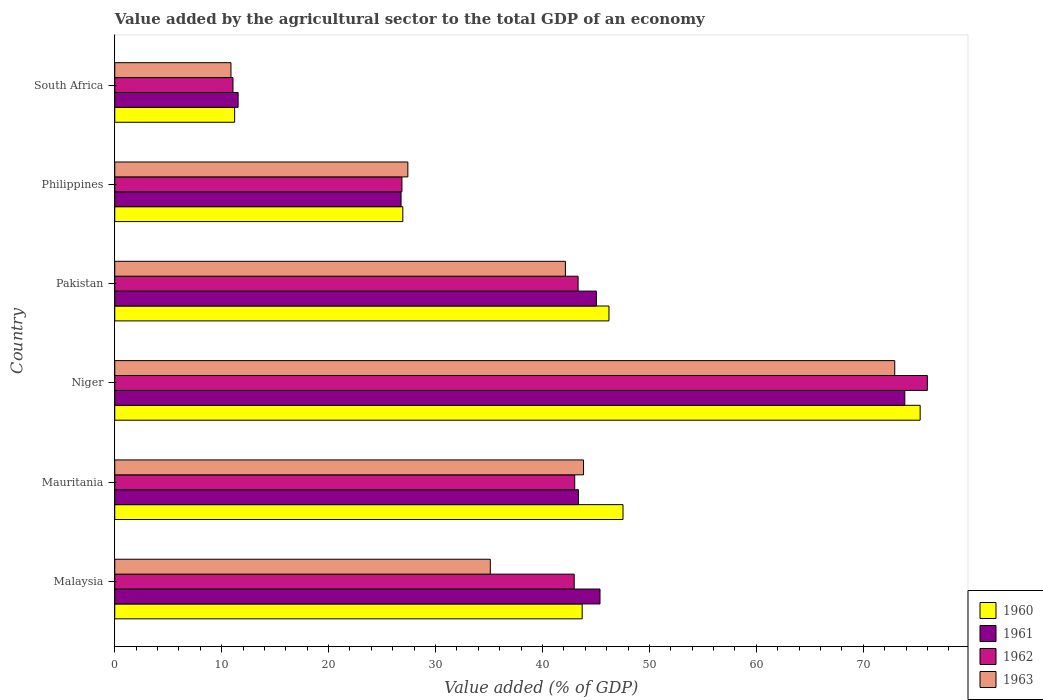How many groups of bars are there?
Your answer should be very brief. 6. Are the number of bars per tick equal to the number of legend labels?
Give a very brief answer. Yes. Are the number of bars on each tick of the Y-axis equal?
Make the answer very short. Yes. How many bars are there on the 2nd tick from the top?
Provide a succinct answer. 4. How many bars are there on the 6th tick from the bottom?
Your answer should be compact. 4. What is the label of the 1st group of bars from the top?
Offer a very short reply. South Africa. What is the value added by the agricultural sector to the total GDP in 1961 in South Africa?
Your response must be concise. 11.54. Across all countries, what is the maximum value added by the agricultural sector to the total GDP in 1963?
Give a very brief answer. 72.95. Across all countries, what is the minimum value added by the agricultural sector to the total GDP in 1963?
Make the answer very short. 10.87. In which country was the value added by the agricultural sector to the total GDP in 1962 maximum?
Make the answer very short. Niger. In which country was the value added by the agricultural sector to the total GDP in 1960 minimum?
Provide a succinct answer. South Africa. What is the total value added by the agricultural sector to the total GDP in 1960 in the graph?
Give a very brief answer. 250.95. What is the difference between the value added by the agricultural sector to the total GDP in 1963 in Malaysia and that in South Africa?
Your answer should be very brief. 24.25. What is the difference between the value added by the agricultural sector to the total GDP in 1963 in Malaysia and the value added by the agricultural sector to the total GDP in 1960 in Mauritania?
Make the answer very short. -12.41. What is the average value added by the agricultural sector to the total GDP in 1963 per country?
Offer a terse response. 38.72. What is the difference between the value added by the agricultural sector to the total GDP in 1963 and value added by the agricultural sector to the total GDP in 1961 in South Africa?
Provide a succinct answer. -0.67. What is the ratio of the value added by the agricultural sector to the total GDP in 1960 in Malaysia to that in Pakistan?
Offer a terse response. 0.95. Is the difference between the value added by the agricultural sector to the total GDP in 1963 in Mauritania and Pakistan greater than the difference between the value added by the agricultural sector to the total GDP in 1961 in Mauritania and Pakistan?
Your answer should be very brief. Yes. What is the difference between the highest and the second highest value added by the agricultural sector to the total GDP in 1962?
Your answer should be very brief. 32.66. What is the difference between the highest and the lowest value added by the agricultural sector to the total GDP in 1961?
Make the answer very short. 62.35. Is the sum of the value added by the agricultural sector to the total GDP in 1960 in Malaysia and Niger greater than the maximum value added by the agricultural sector to the total GDP in 1961 across all countries?
Offer a very short reply. Yes. Is it the case that in every country, the sum of the value added by the agricultural sector to the total GDP in 1963 and value added by the agricultural sector to the total GDP in 1962 is greater than the sum of value added by the agricultural sector to the total GDP in 1961 and value added by the agricultural sector to the total GDP in 1960?
Offer a terse response. No. What does the 1st bar from the top in Mauritania represents?
Your answer should be very brief. 1963. What does the 3rd bar from the bottom in Malaysia represents?
Your answer should be very brief. 1962. Are all the bars in the graph horizontal?
Keep it short and to the point. Yes. How many countries are there in the graph?
Your answer should be very brief. 6. Does the graph contain grids?
Your answer should be compact. No. What is the title of the graph?
Provide a succinct answer. Value added by the agricultural sector to the total GDP of an economy. Does "1986" appear as one of the legend labels in the graph?
Make the answer very short. No. What is the label or title of the X-axis?
Your answer should be compact. Value added (% of GDP). What is the label or title of the Y-axis?
Ensure brevity in your answer.  Country. What is the Value added (% of GDP) of 1960 in Malaysia?
Provide a short and direct response. 43.72. What is the Value added (% of GDP) of 1961 in Malaysia?
Provide a short and direct response. 45.38. What is the Value added (% of GDP) in 1962 in Malaysia?
Your answer should be very brief. 42.97. What is the Value added (% of GDP) in 1963 in Malaysia?
Keep it short and to the point. 35.12. What is the Value added (% of GDP) of 1960 in Mauritania?
Provide a short and direct response. 47.53. What is the Value added (% of GDP) in 1961 in Mauritania?
Provide a succinct answer. 43.37. What is the Value added (% of GDP) of 1962 in Mauritania?
Your answer should be compact. 43.02. What is the Value added (% of GDP) of 1963 in Mauritania?
Provide a short and direct response. 43.84. What is the Value added (% of GDP) of 1960 in Niger?
Your answer should be compact. 75.32. What is the Value added (% of GDP) of 1961 in Niger?
Your response must be concise. 73.89. What is the Value added (% of GDP) of 1962 in Niger?
Offer a very short reply. 76. What is the Value added (% of GDP) in 1963 in Niger?
Your answer should be compact. 72.95. What is the Value added (% of GDP) of 1960 in Pakistan?
Offer a very short reply. 46.22. What is the Value added (% of GDP) in 1961 in Pakistan?
Give a very brief answer. 45.04. What is the Value added (% of GDP) of 1962 in Pakistan?
Give a very brief answer. 43.33. What is the Value added (% of GDP) in 1963 in Pakistan?
Provide a short and direct response. 42.15. What is the Value added (% of GDP) of 1960 in Philippines?
Provide a succinct answer. 26.94. What is the Value added (% of GDP) in 1961 in Philippines?
Offer a terse response. 26.78. What is the Value added (% of GDP) of 1962 in Philippines?
Offer a very short reply. 26.86. What is the Value added (% of GDP) in 1963 in Philippines?
Provide a succinct answer. 27.41. What is the Value added (% of GDP) of 1960 in South Africa?
Your answer should be compact. 11.21. What is the Value added (% of GDP) in 1961 in South Africa?
Your response must be concise. 11.54. What is the Value added (% of GDP) in 1962 in South Africa?
Your response must be concise. 11.06. What is the Value added (% of GDP) in 1963 in South Africa?
Offer a terse response. 10.87. Across all countries, what is the maximum Value added (% of GDP) in 1960?
Keep it short and to the point. 75.32. Across all countries, what is the maximum Value added (% of GDP) in 1961?
Make the answer very short. 73.89. Across all countries, what is the maximum Value added (% of GDP) of 1962?
Keep it short and to the point. 76. Across all countries, what is the maximum Value added (% of GDP) in 1963?
Keep it short and to the point. 72.95. Across all countries, what is the minimum Value added (% of GDP) of 1960?
Offer a very short reply. 11.21. Across all countries, what is the minimum Value added (% of GDP) of 1961?
Give a very brief answer. 11.54. Across all countries, what is the minimum Value added (% of GDP) of 1962?
Give a very brief answer. 11.06. Across all countries, what is the minimum Value added (% of GDP) in 1963?
Your answer should be compact. 10.87. What is the total Value added (% of GDP) of 1960 in the graph?
Make the answer very short. 250.95. What is the total Value added (% of GDP) of 1961 in the graph?
Keep it short and to the point. 245.99. What is the total Value added (% of GDP) in 1962 in the graph?
Keep it short and to the point. 243.23. What is the total Value added (% of GDP) of 1963 in the graph?
Provide a succinct answer. 232.34. What is the difference between the Value added (% of GDP) of 1960 in Malaysia and that in Mauritania?
Ensure brevity in your answer.  -3.82. What is the difference between the Value added (% of GDP) of 1961 in Malaysia and that in Mauritania?
Your response must be concise. 2.01. What is the difference between the Value added (% of GDP) of 1963 in Malaysia and that in Mauritania?
Offer a terse response. -8.72. What is the difference between the Value added (% of GDP) of 1960 in Malaysia and that in Niger?
Make the answer very short. -31.61. What is the difference between the Value added (% of GDP) of 1961 in Malaysia and that in Niger?
Ensure brevity in your answer.  -28.5. What is the difference between the Value added (% of GDP) of 1962 in Malaysia and that in Niger?
Offer a terse response. -33.03. What is the difference between the Value added (% of GDP) of 1963 in Malaysia and that in Niger?
Make the answer very short. -37.82. What is the difference between the Value added (% of GDP) in 1960 in Malaysia and that in Pakistan?
Make the answer very short. -2.5. What is the difference between the Value added (% of GDP) of 1961 in Malaysia and that in Pakistan?
Offer a terse response. 0.34. What is the difference between the Value added (% of GDP) of 1962 in Malaysia and that in Pakistan?
Keep it short and to the point. -0.36. What is the difference between the Value added (% of GDP) in 1963 in Malaysia and that in Pakistan?
Provide a succinct answer. -7.02. What is the difference between the Value added (% of GDP) in 1960 in Malaysia and that in Philippines?
Offer a terse response. 16.78. What is the difference between the Value added (% of GDP) in 1961 in Malaysia and that in Philippines?
Your answer should be very brief. 18.61. What is the difference between the Value added (% of GDP) of 1962 in Malaysia and that in Philippines?
Give a very brief answer. 16.11. What is the difference between the Value added (% of GDP) of 1963 in Malaysia and that in Philippines?
Your response must be concise. 7.71. What is the difference between the Value added (% of GDP) in 1960 in Malaysia and that in South Africa?
Give a very brief answer. 32.51. What is the difference between the Value added (% of GDP) of 1961 in Malaysia and that in South Africa?
Offer a very short reply. 33.84. What is the difference between the Value added (% of GDP) of 1962 in Malaysia and that in South Africa?
Your response must be concise. 31.91. What is the difference between the Value added (% of GDP) in 1963 in Malaysia and that in South Africa?
Your answer should be very brief. 24.25. What is the difference between the Value added (% of GDP) in 1960 in Mauritania and that in Niger?
Keep it short and to the point. -27.79. What is the difference between the Value added (% of GDP) of 1961 in Mauritania and that in Niger?
Your answer should be very brief. -30.52. What is the difference between the Value added (% of GDP) of 1962 in Mauritania and that in Niger?
Your answer should be very brief. -32.98. What is the difference between the Value added (% of GDP) in 1963 in Mauritania and that in Niger?
Offer a very short reply. -29.11. What is the difference between the Value added (% of GDP) in 1960 in Mauritania and that in Pakistan?
Offer a very short reply. 1.31. What is the difference between the Value added (% of GDP) of 1961 in Mauritania and that in Pakistan?
Keep it short and to the point. -1.68. What is the difference between the Value added (% of GDP) of 1962 in Mauritania and that in Pakistan?
Provide a succinct answer. -0.31. What is the difference between the Value added (% of GDP) of 1963 in Mauritania and that in Pakistan?
Your answer should be compact. 1.69. What is the difference between the Value added (% of GDP) in 1960 in Mauritania and that in Philippines?
Your answer should be very brief. 20.59. What is the difference between the Value added (% of GDP) in 1961 in Mauritania and that in Philippines?
Provide a succinct answer. 16.59. What is the difference between the Value added (% of GDP) of 1962 in Mauritania and that in Philippines?
Your response must be concise. 16.16. What is the difference between the Value added (% of GDP) in 1963 in Mauritania and that in Philippines?
Offer a very short reply. 16.43. What is the difference between the Value added (% of GDP) of 1960 in Mauritania and that in South Africa?
Make the answer very short. 36.32. What is the difference between the Value added (% of GDP) of 1961 in Mauritania and that in South Africa?
Offer a terse response. 31.83. What is the difference between the Value added (% of GDP) of 1962 in Mauritania and that in South Africa?
Keep it short and to the point. 31.96. What is the difference between the Value added (% of GDP) in 1963 in Mauritania and that in South Africa?
Offer a very short reply. 32.97. What is the difference between the Value added (% of GDP) in 1960 in Niger and that in Pakistan?
Offer a terse response. 29.1. What is the difference between the Value added (% of GDP) of 1961 in Niger and that in Pakistan?
Your response must be concise. 28.84. What is the difference between the Value added (% of GDP) in 1962 in Niger and that in Pakistan?
Keep it short and to the point. 32.66. What is the difference between the Value added (% of GDP) of 1963 in Niger and that in Pakistan?
Make the answer very short. 30.8. What is the difference between the Value added (% of GDP) of 1960 in Niger and that in Philippines?
Your answer should be compact. 48.38. What is the difference between the Value added (% of GDP) of 1961 in Niger and that in Philippines?
Keep it short and to the point. 47.11. What is the difference between the Value added (% of GDP) in 1962 in Niger and that in Philippines?
Offer a terse response. 49.14. What is the difference between the Value added (% of GDP) of 1963 in Niger and that in Philippines?
Make the answer very short. 45.54. What is the difference between the Value added (% of GDP) in 1960 in Niger and that in South Africa?
Give a very brief answer. 64.11. What is the difference between the Value added (% of GDP) in 1961 in Niger and that in South Africa?
Offer a very short reply. 62.35. What is the difference between the Value added (% of GDP) of 1962 in Niger and that in South Africa?
Your answer should be very brief. 64.94. What is the difference between the Value added (% of GDP) in 1963 in Niger and that in South Africa?
Make the answer very short. 62.08. What is the difference between the Value added (% of GDP) of 1960 in Pakistan and that in Philippines?
Your response must be concise. 19.28. What is the difference between the Value added (% of GDP) of 1961 in Pakistan and that in Philippines?
Keep it short and to the point. 18.27. What is the difference between the Value added (% of GDP) in 1962 in Pakistan and that in Philippines?
Provide a succinct answer. 16.48. What is the difference between the Value added (% of GDP) in 1963 in Pakistan and that in Philippines?
Keep it short and to the point. 14.73. What is the difference between the Value added (% of GDP) of 1960 in Pakistan and that in South Africa?
Your response must be concise. 35.01. What is the difference between the Value added (% of GDP) of 1961 in Pakistan and that in South Africa?
Make the answer very short. 33.51. What is the difference between the Value added (% of GDP) in 1962 in Pakistan and that in South Africa?
Provide a short and direct response. 32.28. What is the difference between the Value added (% of GDP) of 1963 in Pakistan and that in South Africa?
Your answer should be very brief. 31.28. What is the difference between the Value added (% of GDP) of 1960 in Philippines and that in South Africa?
Ensure brevity in your answer.  15.73. What is the difference between the Value added (% of GDP) in 1961 in Philippines and that in South Africa?
Your response must be concise. 15.24. What is the difference between the Value added (% of GDP) in 1962 in Philippines and that in South Africa?
Give a very brief answer. 15.8. What is the difference between the Value added (% of GDP) in 1963 in Philippines and that in South Africa?
Provide a short and direct response. 16.54. What is the difference between the Value added (% of GDP) in 1960 in Malaysia and the Value added (% of GDP) in 1961 in Mauritania?
Keep it short and to the point. 0.35. What is the difference between the Value added (% of GDP) in 1960 in Malaysia and the Value added (% of GDP) in 1962 in Mauritania?
Your answer should be very brief. 0.7. What is the difference between the Value added (% of GDP) of 1960 in Malaysia and the Value added (% of GDP) of 1963 in Mauritania?
Your response must be concise. -0.12. What is the difference between the Value added (% of GDP) in 1961 in Malaysia and the Value added (% of GDP) in 1962 in Mauritania?
Offer a terse response. 2.36. What is the difference between the Value added (% of GDP) in 1961 in Malaysia and the Value added (% of GDP) in 1963 in Mauritania?
Give a very brief answer. 1.54. What is the difference between the Value added (% of GDP) in 1962 in Malaysia and the Value added (% of GDP) in 1963 in Mauritania?
Give a very brief answer. -0.87. What is the difference between the Value added (% of GDP) in 1960 in Malaysia and the Value added (% of GDP) in 1961 in Niger?
Offer a terse response. -30.17. What is the difference between the Value added (% of GDP) in 1960 in Malaysia and the Value added (% of GDP) in 1962 in Niger?
Provide a succinct answer. -32.28. What is the difference between the Value added (% of GDP) of 1960 in Malaysia and the Value added (% of GDP) of 1963 in Niger?
Your response must be concise. -29.23. What is the difference between the Value added (% of GDP) in 1961 in Malaysia and the Value added (% of GDP) in 1962 in Niger?
Your answer should be very brief. -30.62. What is the difference between the Value added (% of GDP) in 1961 in Malaysia and the Value added (% of GDP) in 1963 in Niger?
Offer a very short reply. -27.57. What is the difference between the Value added (% of GDP) in 1962 in Malaysia and the Value added (% of GDP) in 1963 in Niger?
Make the answer very short. -29.98. What is the difference between the Value added (% of GDP) in 1960 in Malaysia and the Value added (% of GDP) in 1961 in Pakistan?
Keep it short and to the point. -1.33. What is the difference between the Value added (% of GDP) in 1960 in Malaysia and the Value added (% of GDP) in 1962 in Pakistan?
Your answer should be very brief. 0.38. What is the difference between the Value added (% of GDP) in 1960 in Malaysia and the Value added (% of GDP) in 1963 in Pakistan?
Keep it short and to the point. 1.57. What is the difference between the Value added (% of GDP) of 1961 in Malaysia and the Value added (% of GDP) of 1962 in Pakistan?
Make the answer very short. 2.05. What is the difference between the Value added (% of GDP) of 1961 in Malaysia and the Value added (% of GDP) of 1963 in Pakistan?
Your answer should be very brief. 3.24. What is the difference between the Value added (% of GDP) of 1962 in Malaysia and the Value added (% of GDP) of 1963 in Pakistan?
Make the answer very short. 0.82. What is the difference between the Value added (% of GDP) in 1960 in Malaysia and the Value added (% of GDP) in 1961 in Philippines?
Provide a succinct answer. 16.94. What is the difference between the Value added (% of GDP) of 1960 in Malaysia and the Value added (% of GDP) of 1962 in Philippines?
Give a very brief answer. 16.86. What is the difference between the Value added (% of GDP) of 1960 in Malaysia and the Value added (% of GDP) of 1963 in Philippines?
Your answer should be very brief. 16.3. What is the difference between the Value added (% of GDP) of 1961 in Malaysia and the Value added (% of GDP) of 1962 in Philippines?
Offer a terse response. 18.52. What is the difference between the Value added (% of GDP) of 1961 in Malaysia and the Value added (% of GDP) of 1963 in Philippines?
Make the answer very short. 17.97. What is the difference between the Value added (% of GDP) in 1962 in Malaysia and the Value added (% of GDP) in 1963 in Philippines?
Offer a terse response. 15.56. What is the difference between the Value added (% of GDP) in 1960 in Malaysia and the Value added (% of GDP) in 1961 in South Africa?
Provide a succinct answer. 32.18. What is the difference between the Value added (% of GDP) in 1960 in Malaysia and the Value added (% of GDP) in 1962 in South Africa?
Your answer should be compact. 32.66. What is the difference between the Value added (% of GDP) of 1960 in Malaysia and the Value added (% of GDP) of 1963 in South Africa?
Your answer should be compact. 32.85. What is the difference between the Value added (% of GDP) of 1961 in Malaysia and the Value added (% of GDP) of 1962 in South Africa?
Your answer should be compact. 34.33. What is the difference between the Value added (% of GDP) in 1961 in Malaysia and the Value added (% of GDP) in 1963 in South Africa?
Your answer should be very brief. 34.51. What is the difference between the Value added (% of GDP) in 1962 in Malaysia and the Value added (% of GDP) in 1963 in South Africa?
Your answer should be compact. 32.1. What is the difference between the Value added (% of GDP) in 1960 in Mauritania and the Value added (% of GDP) in 1961 in Niger?
Your answer should be compact. -26.35. What is the difference between the Value added (% of GDP) in 1960 in Mauritania and the Value added (% of GDP) in 1962 in Niger?
Offer a terse response. -28.46. What is the difference between the Value added (% of GDP) of 1960 in Mauritania and the Value added (% of GDP) of 1963 in Niger?
Keep it short and to the point. -25.41. What is the difference between the Value added (% of GDP) in 1961 in Mauritania and the Value added (% of GDP) in 1962 in Niger?
Provide a short and direct response. -32.63. What is the difference between the Value added (% of GDP) of 1961 in Mauritania and the Value added (% of GDP) of 1963 in Niger?
Offer a very short reply. -29.58. What is the difference between the Value added (% of GDP) of 1962 in Mauritania and the Value added (% of GDP) of 1963 in Niger?
Your response must be concise. -29.93. What is the difference between the Value added (% of GDP) of 1960 in Mauritania and the Value added (% of GDP) of 1961 in Pakistan?
Keep it short and to the point. 2.49. What is the difference between the Value added (% of GDP) of 1960 in Mauritania and the Value added (% of GDP) of 1962 in Pakistan?
Ensure brevity in your answer.  4.2. What is the difference between the Value added (% of GDP) in 1960 in Mauritania and the Value added (% of GDP) in 1963 in Pakistan?
Offer a very short reply. 5.39. What is the difference between the Value added (% of GDP) in 1961 in Mauritania and the Value added (% of GDP) in 1962 in Pakistan?
Provide a succinct answer. 0.03. What is the difference between the Value added (% of GDP) of 1961 in Mauritania and the Value added (% of GDP) of 1963 in Pakistan?
Make the answer very short. 1.22. What is the difference between the Value added (% of GDP) in 1962 in Mauritania and the Value added (% of GDP) in 1963 in Pakistan?
Make the answer very short. 0.87. What is the difference between the Value added (% of GDP) of 1960 in Mauritania and the Value added (% of GDP) of 1961 in Philippines?
Your answer should be compact. 20.76. What is the difference between the Value added (% of GDP) in 1960 in Mauritania and the Value added (% of GDP) in 1962 in Philippines?
Offer a very short reply. 20.68. What is the difference between the Value added (% of GDP) of 1960 in Mauritania and the Value added (% of GDP) of 1963 in Philippines?
Offer a very short reply. 20.12. What is the difference between the Value added (% of GDP) of 1961 in Mauritania and the Value added (% of GDP) of 1962 in Philippines?
Your response must be concise. 16.51. What is the difference between the Value added (% of GDP) in 1961 in Mauritania and the Value added (% of GDP) in 1963 in Philippines?
Provide a short and direct response. 15.96. What is the difference between the Value added (% of GDP) in 1962 in Mauritania and the Value added (% of GDP) in 1963 in Philippines?
Offer a terse response. 15.61. What is the difference between the Value added (% of GDP) of 1960 in Mauritania and the Value added (% of GDP) of 1961 in South Africa?
Offer a terse response. 36. What is the difference between the Value added (% of GDP) of 1960 in Mauritania and the Value added (% of GDP) of 1962 in South Africa?
Make the answer very short. 36.48. What is the difference between the Value added (% of GDP) in 1960 in Mauritania and the Value added (% of GDP) in 1963 in South Africa?
Offer a very short reply. 36.67. What is the difference between the Value added (% of GDP) of 1961 in Mauritania and the Value added (% of GDP) of 1962 in South Africa?
Ensure brevity in your answer.  32.31. What is the difference between the Value added (% of GDP) in 1961 in Mauritania and the Value added (% of GDP) in 1963 in South Africa?
Provide a short and direct response. 32.5. What is the difference between the Value added (% of GDP) in 1962 in Mauritania and the Value added (% of GDP) in 1963 in South Africa?
Offer a terse response. 32.15. What is the difference between the Value added (% of GDP) in 1960 in Niger and the Value added (% of GDP) in 1961 in Pakistan?
Provide a short and direct response. 30.28. What is the difference between the Value added (% of GDP) of 1960 in Niger and the Value added (% of GDP) of 1962 in Pakistan?
Give a very brief answer. 31.99. What is the difference between the Value added (% of GDP) in 1960 in Niger and the Value added (% of GDP) in 1963 in Pakistan?
Give a very brief answer. 33.18. What is the difference between the Value added (% of GDP) of 1961 in Niger and the Value added (% of GDP) of 1962 in Pakistan?
Offer a very short reply. 30.55. What is the difference between the Value added (% of GDP) in 1961 in Niger and the Value added (% of GDP) in 1963 in Pakistan?
Your answer should be very brief. 31.74. What is the difference between the Value added (% of GDP) of 1962 in Niger and the Value added (% of GDP) of 1963 in Pakistan?
Offer a terse response. 33.85. What is the difference between the Value added (% of GDP) in 1960 in Niger and the Value added (% of GDP) in 1961 in Philippines?
Your answer should be very brief. 48.55. What is the difference between the Value added (% of GDP) in 1960 in Niger and the Value added (% of GDP) in 1962 in Philippines?
Your answer should be compact. 48.47. What is the difference between the Value added (% of GDP) in 1960 in Niger and the Value added (% of GDP) in 1963 in Philippines?
Give a very brief answer. 47.91. What is the difference between the Value added (% of GDP) in 1961 in Niger and the Value added (% of GDP) in 1962 in Philippines?
Make the answer very short. 47.03. What is the difference between the Value added (% of GDP) of 1961 in Niger and the Value added (% of GDP) of 1963 in Philippines?
Keep it short and to the point. 46.48. What is the difference between the Value added (% of GDP) of 1962 in Niger and the Value added (% of GDP) of 1963 in Philippines?
Ensure brevity in your answer.  48.59. What is the difference between the Value added (% of GDP) of 1960 in Niger and the Value added (% of GDP) of 1961 in South Africa?
Make the answer very short. 63.79. What is the difference between the Value added (% of GDP) of 1960 in Niger and the Value added (% of GDP) of 1962 in South Africa?
Your response must be concise. 64.27. What is the difference between the Value added (% of GDP) of 1960 in Niger and the Value added (% of GDP) of 1963 in South Africa?
Your response must be concise. 64.46. What is the difference between the Value added (% of GDP) in 1961 in Niger and the Value added (% of GDP) in 1962 in South Africa?
Provide a short and direct response. 62.83. What is the difference between the Value added (% of GDP) in 1961 in Niger and the Value added (% of GDP) in 1963 in South Africa?
Offer a very short reply. 63.02. What is the difference between the Value added (% of GDP) of 1962 in Niger and the Value added (% of GDP) of 1963 in South Africa?
Your answer should be compact. 65.13. What is the difference between the Value added (% of GDP) in 1960 in Pakistan and the Value added (% of GDP) in 1961 in Philippines?
Provide a succinct answer. 19.44. What is the difference between the Value added (% of GDP) of 1960 in Pakistan and the Value added (% of GDP) of 1962 in Philippines?
Offer a very short reply. 19.36. What is the difference between the Value added (% of GDP) of 1960 in Pakistan and the Value added (% of GDP) of 1963 in Philippines?
Offer a very short reply. 18.81. What is the difference between the Value added (% of GDP) in 1961 in Pakistan and the Value added (% of GDP) in 1962 in Philippines?
Offer a very short reply. 18.19. What is the difference between the Value added (% of GDP) in 1961 in Pakistan and the Value added (% of GDP) in 1963 in Philippines?
Give a very brief answer. 17.63. What is the difference between the Value added (% of GDP) of 1962 in Pakistan and the Value added (% of GDP) of 1963 in Philippines?
Make the answer very short. 15.92. What is the difference between the Value added (% of GDP) of 1960 in Pakistan and the Value added (% of GDP) of 1961 in South Africa?
Provide a short and direct response. 34.68. What is the difference between the Value added (% of GDP) in 1960 in Pakistan and the Value added (% of GDP) in 1962 in South Africa?
Keep it short and to the point. 35.16. What is the difference between the Value added (% of GDP) of 1960 in Pakistan and the Value added (% of GDP) of 1963 in South Africa?
Give a very brief answer. 35.35. What is the difference between the Value added (% of GDP) of 1961 in Pakistan and the Value added (% of GDP) of 1962 in South Africa?
Your answer should be compact. 33.99. What is the difference between the Value added (% of GDP) in 1961 in Pakistan and the Value added (% of GDP) in 1963 in South Africa?
Your answer should be very brief. 34.17. What is the difference between the Value added (% of GDP) of 1962 in Pakistan and the Value added (% of GDP) of 1963 in South Africa?
Keep it short and to the point. 32.46. What is the difference between the Value added (% of GDP) of 1960 in Philippines and the Value added (% of GDP) of 1961 in South Africa?
Provide a short and direct response. 15.4. What is the difference between the Value added (% of GDP) of 1960 in Philippines and the Value added (% of GDP) of 1962 in South Africa?
Your answer should be very brief. 15.88. What is the difference between the Value added (% of GDP) of 1960 in Philippines and the Value added (% of GDP) of 1963 in South Africa?
Your response must be concise. 16.07. What is the difference between the Value added (% of GDP) in 1961 in Philippines and the Value added (% of GDP) in 1962 in South Africa?
Ensure brevity in your answer.  15.72. What is the difference between the Value added (% of GDP) in 1961 in Philippines and the Value added (% of GDP) in 1963 in South Africa?
Give a very brief answer. 15.91. What is the difference between the Value added (% of GDP) of 1962 in Philippines and the Value added (% of GDP) of 1963 in South Africa?
Provide a short and direct response. 15.99. What is the average Value added (% of GDP) of 1960 per country?
Your answer should be compact. 41.82. What is the average Value added (% of GDP) in 1961 per country?
Give a very brief answer. 41. What is the average Value added (% of GDP) of 1962 per country?
Make the answer very short. 40.54. What is the average Value added (% of GDP) of 1963 per country?
Make the answer very short. 38.72. What is the difference between the Value added (% of GDP) of 1960 and Value added (% of GDP) of 1961 in Malaysia?
Provide a short and direct response. -1.67. What is the difference between the Value added (% of GDP) in 1960 and Value added (% of GDP) in 1962 in Malaysia?
Provide a short and direct response. 0.75. What is the difference between the Value added (% of GDP) in 1960 and Value added (% of GDP) in 1963 in Malaysia?
Your answer should be very brief. 8.59. What is the difference between the Value added (% of GDP) in 1961 and Value added (% of GDP) in 1962 in Malaysia?
Ensure brevity in your answer.  2.41. What is the difference between the Value added (% of GDP) of 1961 and Value added (% of GDP) of 1963 in Malaysia?
Keep it short and to the point. 10.26. What is the difference between the Value added (% of GDP) of 1962 and Value added (% of GDP) of 1963 in Malaysia?
Your answer should be very brief. 7.84. What is the difference between the Value added (% of GDP) in 1960 and Value added (% of GDP) in 1961 in Mauritania?
Ensure brevity in your answer.  4.17. What is the difference between the Value added (% of GDP) in 1960 and Value added (% of GDP) in 1962 in Mauritania?
Keep it short and to the point. 4.52. What is the difference between the Value added (% of GDP) of 1960 and Value added (% of GDP) of 1963 in Mauritania?
Your answer should be compact. 3.69. What is the difference between the Value added (% of GDP) in 1961 and Value added (% of GDP) in 1962 in Mauritania?
Give a very brief answer. 0.35. What is the difference between the Value added (% of GDP) in 1961 and Value added (% of GDP) in 1963 in Mauritania?
Give a very brief answer. -0.47. What is the difference between the Value added (% of GDP) of 1962 and Value added (% of GDP) of 1963 in Mauritania?
Provide a short and direct response. -0.82. What is the difference between the Value added (% of GDP) in 1960 and Value added (% of GDP) in 1961 in Niger?
Your answer should be very brief. 1.44. What is the difference between the Value added (% of GDP) in 1960 and Value added (% of GDP) in 1962 in Niger?
Your answer should be compact. -0.67. What is the difference between the Value added (% of GDP) of 1960 and Value added (% of GDP) of 1963 in Niger?
Provide a short and direct response. 2.38. What is the difference between the Value added (% of GDP) in 1961 and Value added (% of GDP) in 1962 in Niger?
Your answer should be compact. -2.11. What is the difference between the Value added (% of GDP) in 1961 and Value added (% of GDP) in 1963 in Niger?
Your response must be concise. 0.94. What is the difference between the Value added (% of GDP) in 1962 and Value added (% of GDP) in 1963 in Niger?
Provide a short and direct response. 3.05. What is the difference between the Value added (% of GDP) in 1960 and Value added (% of GDP) in 1961 in Pakistan?
Make the answer very short. 1.18. What is the difference between the Value added (% of GDP) in 1960 and Value added (% of GDP) in 1962 in Pakistan?
Provide a succinct answer. 2.89. What is the difference between the Value added (% of GDP) of 1960 and Value added (% of GDP) of 1963 in Pakistan?
Keep it short and to the point. 4.07. What is the difference between the Value added (% of GDP) in 1961 and Value added (% of GDP) in 1962 in Pakistan?
Make the answer very short. 1.71. What is the difference between the Value added (% of GDP) of 1961 and Value added (% of GDP) of 1963 in Pakistan?
Make the answer very short. 2.9. What is the difference between the Value added (% of GDP) of 1962 and Value added (% of GDP) of 1963 in Pakistan?
Your answer should be very brief. 1.19. What is the difference between the Value added (% of GDP) in 1960 and Value added (% of GDP) in 1961 in Philippines?
Make the answer very short. 0.16. What is the difference between the Value added (% of GDP) in 1960 and Value added (% of GDP) in 1962 in Philippines?
Keep it short and to the point. 0.08. What is the difference between the Value added (% of GDP) in 1960 and Value added (% of GDP) in 1963 in Philippines?
Keep it short and to the point. -0.47. What is the difference between the Value added (% of GDP) in 1961 and Value added (% of GDP) in 1962 in Philippines?
Offer a terse response. -0.08. What is the difference between the Value added (% of GDP) of 1961 and Value added (% of GDP) of 1963 in Philippines?
Provide a short and direct response. -0.64. What is the difference between the Value added (% of GDP) in 1962 and Value added (% of GDP) in 1963 in Philippines?
Give a very brief answer. -0.55. What is the difference between the Value added (% of GDP) in 1960 and Value added (% of GDP) in 1961 in South Africa?
Offer a very short reply. -0.33. What is the difference between the Value added (% of GDP) in 1960 and Value added (% of GDP) in 1962 in South Africa?
Offer a terse response. 0.15. What is the difference between the Value added (% of GDP) in 1960 and Value added (% of GDP) in 1963 in South Africa?
Ensure brevity in your answer.  0.34. What is the difference between the Value added (% of GDP) of 1961 and Value added (% of GDP) of 1962 in South Africa?
Provide a succinct answer. 0.48. What is the difference between the Value added (% of GDP) of 1961 and Value added (% of GDP) of 1963 in South Africa?
Give a very brief answer. 0.67. What is the difference between the Value added (% of GDP) of 1962 and Value added (% of GDP) of 1963 in South Africa?
Offer a very short reply. 0.19. What is the ratio of the Value added (% of GDP) in 1960 in Malaysia to that in Mauritania?
Your answer should be compact. 0.92. What is the ratio of the Value added (% of GDP) of 1961 in Malaysia to that in Mauritania?
Provide a short and direct response. 1.05. What is the ratio of the Value added (% of GDP) of 1962 in Malaysia to that in Mauritania?
Give a very brief answer. 1. What is the ratio of the Value added (% of GDP) in 1963 in Malaysia to that in Mauritania?
Give a very brief answer. 0.8. What is the ratio of the Value added (% of GDP) of 1960 in Malaysia to that in Niger?
Offer a terse response. 0.58. What is the ratio of the Value added (% of GDP) in 1961 in Malaysia to that in Niger?
Your response must be concise. 0.61. What is the ratio of the Value added (% of GDP) in 1962 in Malaysia to that in Niger?
Make the answer very short. 0.57. What is the ratio of the Value added (% of GDP) in 1963 in Malaysia to that in Niger?
Ensure brevity in your answer.  0.48. What is the ratio of the Value added (% of GDP) of 1960 in Malaysia to that in Pakistan?
Offer a very short reply. 0.95. What is the ratio of the Value added (% of GDP) of 1961 in Malaysia to that in Pakistan?
Your answer should be compact. 1.01. What is the ratio of the Value added (% of GDP) in 1962 in Malaysia to that in Pakistan?
Make the answer very short. 0.99. What is the ratio of the Value added (% of GDP) in 1963 in Malaysia to that in Pakistan?
Your response must be concise. 0.83. What is the ratio of the Value added (% of GDP) of 1960 in Malaysia to that in Philippines?
Offer a very short reply. 1.62. What is the ratio of the Value added (% of GDP) in 1961 in Malaysia to that in Philippines?
Make the answer very short. 1.69. What is the ratio of the Value added (% of GDP) in 1962 in Malaysia to that in Philippines?
Give a very brief answer. 1.6. What is the ratio of the Value added (% of GDP) in 1963 in Malaysia to that in Philippines?
Make the answer very short. 1.28. What is the ratio of the Value added (% of GDP) in 1960 in Malaysia to that in South Africa?
Provide a short and direct response. 3.9. What is the ratio of the Value added (% of GDP) in 1961 in Malaysia to that in South Africa?
Your response must be concise. 3.93. What is the ratio of the Value added (% of GDP) of 1962 in Malaysia to that in South Africa?
Offer a terse response. 3.89. What is the ratio of the Value added (% of GDP) in 1963 in Malaysia to that in South Africa?
Make the answer very short. 3.23. What is the ratio of the Value added (% of GDP) in 1960 in Mauritania to that in Niger?
Your answer should be very brief. 0.63. What is the ratio of the Value added (% of GDP) of 1961 in Mauritania to that in Niger?
Ensure brevity in your answer.  0.59. What is the ratio of the Value added (% of GDP) in 1962 in Mauritania to that in Niger?
Give a very brief answer. 0.57. What is the ratio of the Value added (% of GDP) of 1963 in Mauritania to that in Niger?
Make the answer very short. 0.6. What is the ratio of the Value added (% of GDP) of 1960 in Mauritania to that in Pakistan?
Give a very brief answer. 1.03. What is the ratio of the Value added (% of GDP) of 1961 in Mauritania to that in Pakistan?
Make the answer very short. 0.96. What is the ratio of the Value added (% of GDP) of 1963 in Mauritania to that in Pakistan?
Ensure brevity in your answer.  1.04. What is the ratio of the Value added (% of GDP) in 1960 in Mauritania to that in Philippines?
Offer a terse response. 1.76. What is the ratio of the Value added (% of GDP) in 1961 in Mauritania to that in Philippines?
Your answer should be compact. 1.62. What is the ratio of the Value added (% of GDP) of 1962 in Mauritania to that in Philippines?
Provide a short and direct response. 1.6. What is the ratio of the Value added (% of GDP) of 1963 in Mauritania to that in Philippines?
Make the answer very short. 1.6. What is the ratio of the Value added (% of GDP) of 1960 in Mauritania to that in South Africa?
Offer a very short reply. 4.24. What is the ratio of the Value added (% of GDP) of 1961 in Mauritania to that in South Africa?
Make the answer very short. 3.76. What is the ratio of the Value added (% of GDP) of 1962 in Mauritania to that in South Africa?
Offer a terse response. 3.89. What is the ratio of the Value added (% of GDP) of 1963 in Mauritania to that in South Africa?
Give a very brief answer. 4.03. What is the ratio of the Value added (% of GDP) in 1960 in Niger to that in Pakistan?
Provide a short and direct response. 1.63. What is the ratio of the Value added (% of GDP) in 1961 in Niger to that in Pakistan?
Your answer should be compact. 1.64. What is the ratio of the Value added (% of GDP) of 1962 in Niger to that in Pakistan?
Give a very brief answer. 1.75. What is the ratio of the Value added (% of GDP) of 1963 in Niger to that in Pakistan?
Your answer should be compact. 1.73. What is the ratio of the Value added (% of GDP) of 1960 in Niger to that in Philippines?
Ensure brevity in your answer.  2.8. What is the ratio of the Value added (% of GDP) in 1961 in Niger to that in Philippines?
Provide a short and direct response. 2.76. What is the ratio of the Value added (% of GDP) in 1962 in Niger to that in Philippines?
Provide a succinct answer. 2.83. What is the ratio of the Value added (% of GDP) in 1963 in Niger to that in Philippines?
Offer a very short reply. 2.66. What is the ratio of the Value added (% of GDP) in 1960 in Niger to that in South Africa?
Your answer should be very brief. 6.72. What is the ratio of the Value added (% of GDP) of 1961 in Niger to that in South Africa?
Your answer should be very brief. 6.4. What is the ratio of the Value added (% of GDP) of 1962 in Niger to that in South Africa?
Ensure brevity in your answer.  6.87. What is the ratio of the Value added (% of GDP) in 1963 in Niger to that in South Africa?
Give a very brief answer. 6.71. What is the ratio of the Value added (% of GDP) in 1960 in Pakistan to that in Philippines?
Provide a succinct answer. 1.72. What is the ratio of the Value added (% of GDP) in 1961 in Pakistan to that in Philippines?
Your answer should be very brief. 1.68. What is the ratio of the Value added (% of GDP) of 1962 in Pakistan to that in Philippines?
Provide a short and direct response. 1.61. What is the ratio of the Value added (% of GDP) in 1963 in Pakistan to that in Philippines?
Give a very brief answer. 1.54. What is the ratio of the Value added (% of GDP) in 1960 in Pakistan to that in South Africa?
Ensure brevity in your answer.  4.12. What is the ratio of the Value added (% of GDP) of 1961 in Pakistan to that in South Africa?
Give a very brief answer. 3.9. What is the ratio of the Value added (% of GDP) in 1962 in Pakistan to that in South Africa?
Your answer should be compact. 3.92. What is the ratio of the Value added (% of GDP) of 1963 in Pakistan to that in South Africa?
Offer a terse response. 3.88. What is the ratio of the Value added (% of GDP) of 1960 in Philippines to that in South Africa?
Offer a terse response. 2.4. What is the ratio of the Value added (% of GDP) of 1961 in Philippines to that in South Africa?
Your answer should be very brief. 2.32. What is the ratio of the Value added (% of GDP) in 1962 in Philippines to that in South Africa?
Offer a very short reply. 2.43. What is the ratio of the Value added (% of GDP) of 1963 in Philippines to that in South Africa?
Your answer should be compact. 2.52. What is the difference between the highest and the second highest Value added (% of GDP) in 1960?
Your response must be concise. 27.79. What is the difference between the highest and the second highest Value added (% of GDP) of 1961?
Offer a very short reply. 28.5. What is the difference between the highest and the second highest Value added (% of GDP) in 1962?
Make the answer very short. 32.66. What is the difference between the highest and the second highest Value added (% of GDP) in 1963?
Give a very brief answer. 29.11. What is the difference between the highest and the lowest Value added (% of GDP) in 1960?
Offer a terse response. 64.11. What is the difference between the highest and the lowest Value added (% of GDP) of 1961?
Your response must be concise. 62.35. What is the difference between the highest and the lowest Value added (% of GDP) of 1962?
Provide a succinct answer. 64.94. What is the difference between the highest and the lowest Value added (% of GDP) of 1963?
Your answer should be compact. 62.08. 